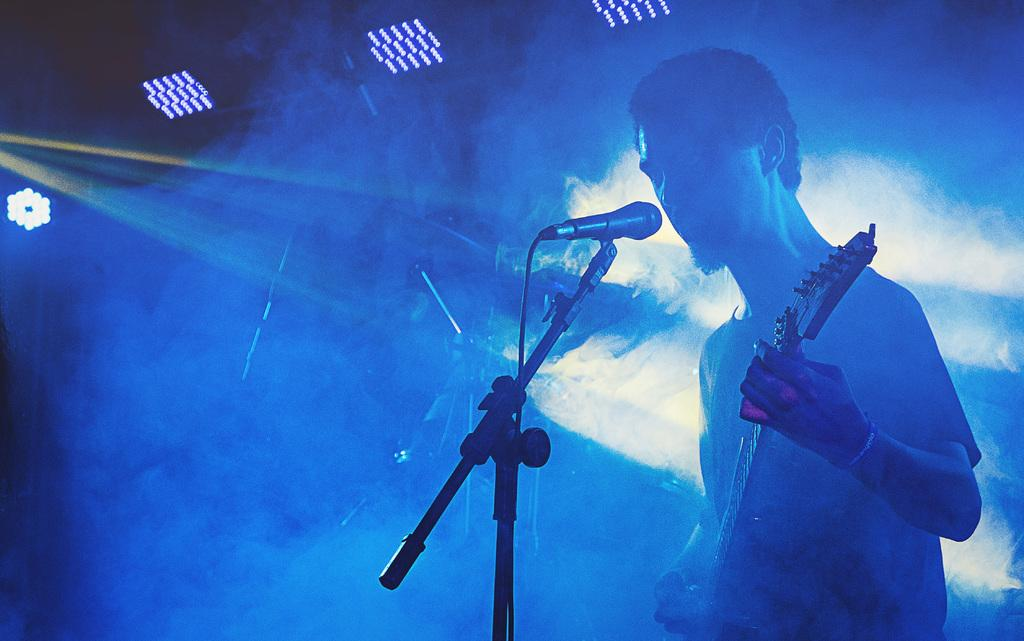What is the person in the image doing? The person is holding a guitar. What object is in front of the person? There is a microphone in front of the person. What can be seen in the background of the image? There are lights visible in the background. What color is the hand-drawn mark on the person's shirt in the image? There is no hand-drawn mark on the person's shirt in the image. 